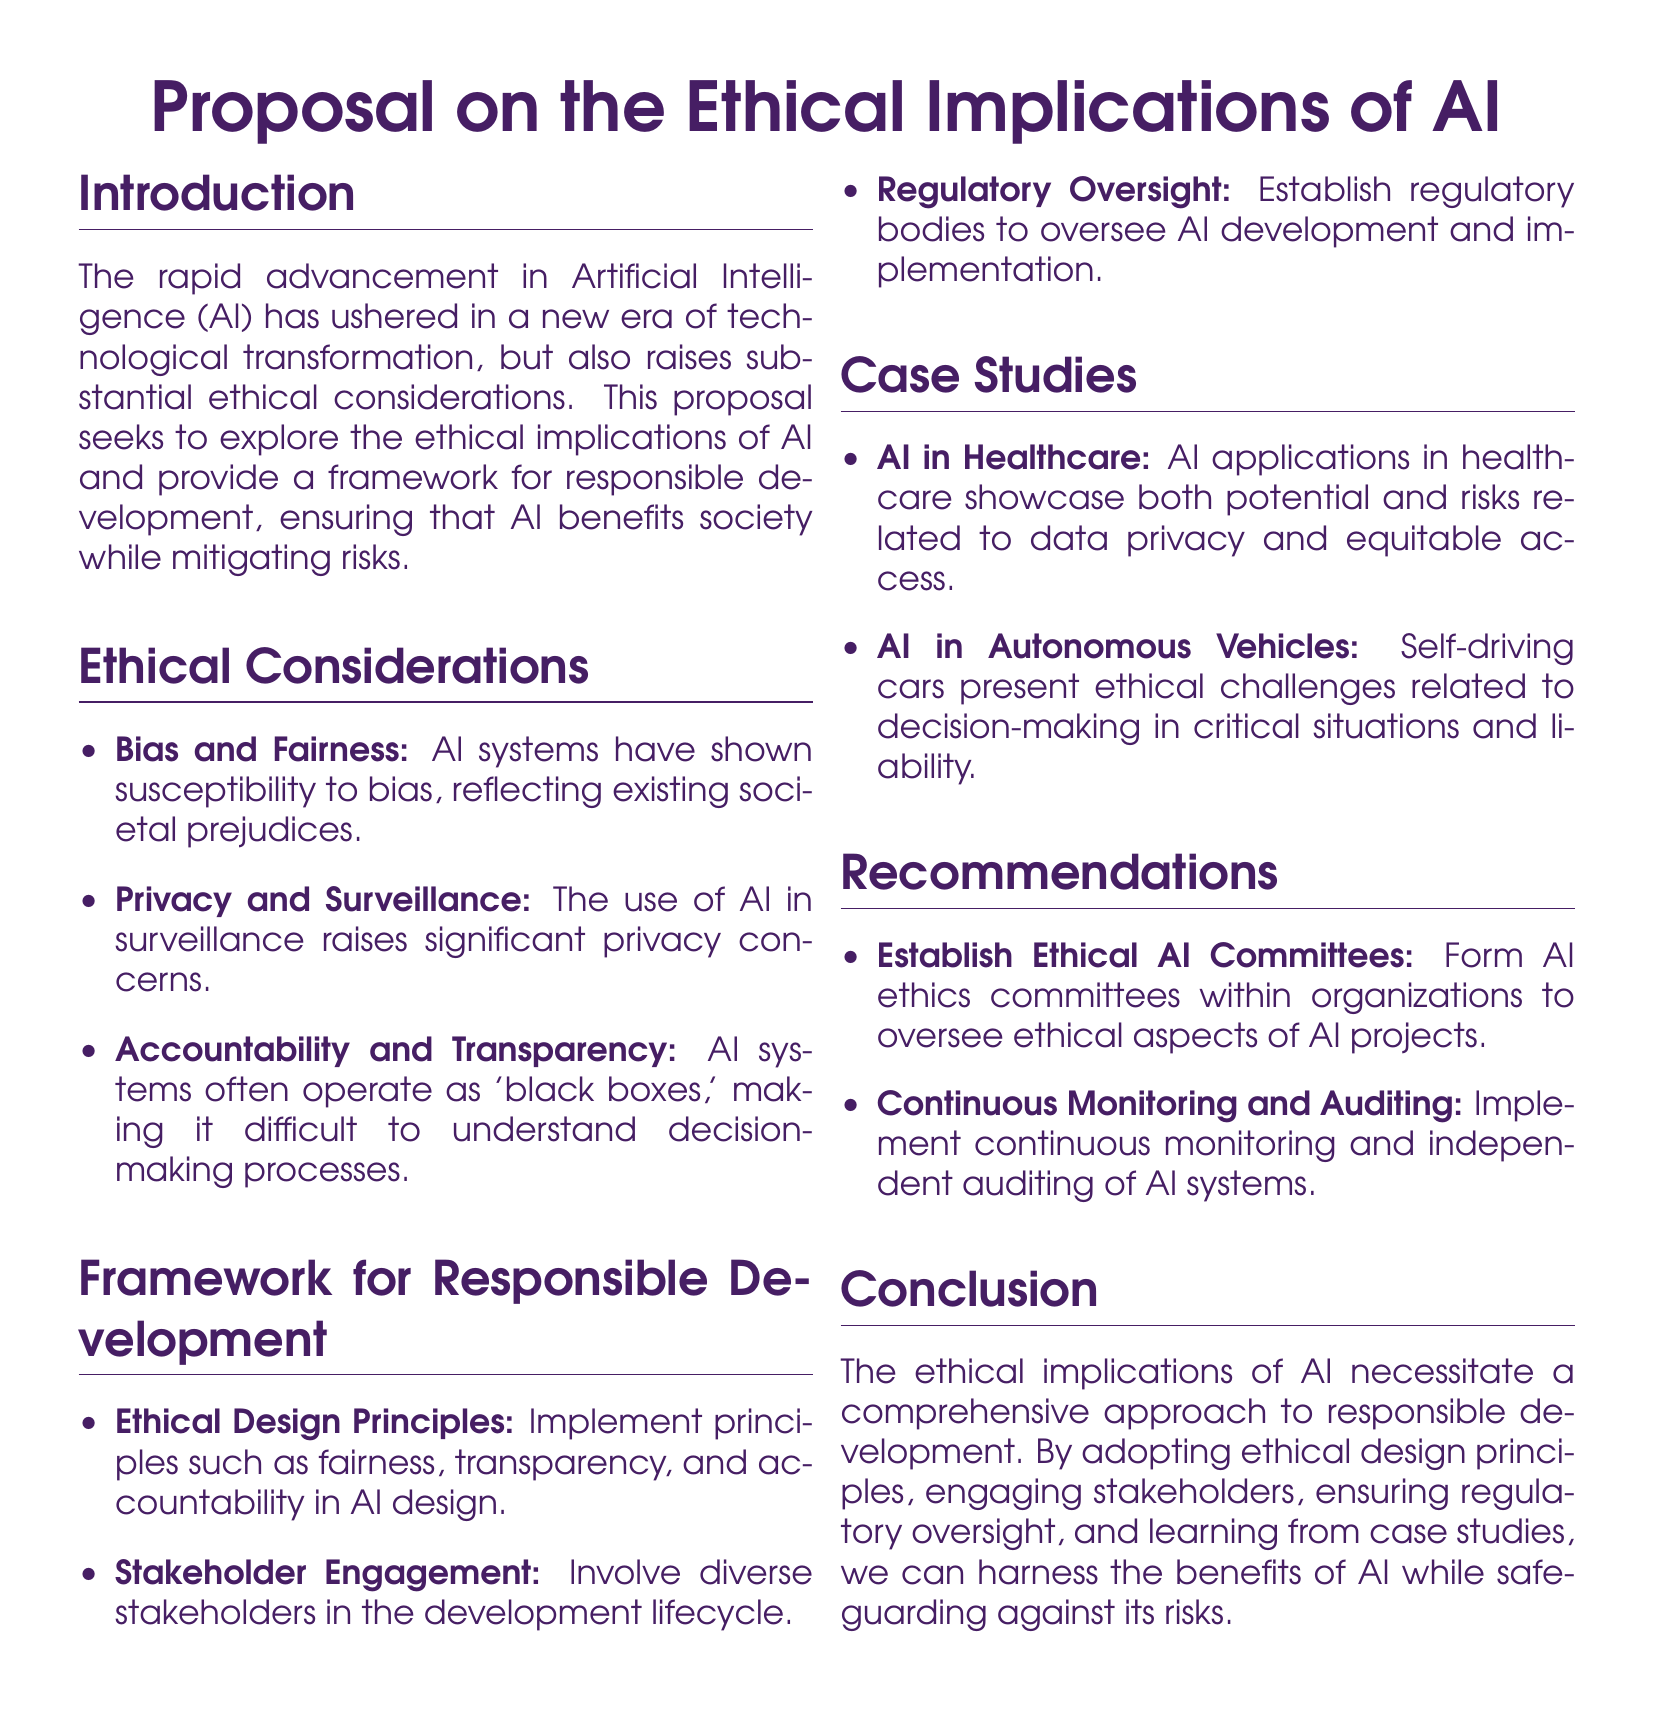What are the main ethical considerations mentioned? The main ethical considerations include bias and fairness, privacy and surveillance, and accountability and transparency.
Answer: bias and fairness, privacy and surveillance, accountability and transparency What is the main purpose of the proposal? The main purpose of the proposal is to explore the ethical implications of AI and provide a framework for responsible development.
Answer: explore the ethical implications of AI and provide a framework for responsible development What is one of the case studies discussed? The proposal outlines specific examples for deeper insight, one of which is AI in healthcare.
Answer: AI in healthcare What is recommended to oversee ethical aspects of AI projects? The proposal suggests forming AI ethics committees within organizations.
Answer: form AI ethics committees What role does stakeholder engagement play? Stakeholder engagement involves diverse stakeholders in the development lifecycle, aiming for inclusivity and varied perspectives.
Answer: involves diverse stakeholders in the development lifecycle What is a proposed method for ensuring transparency in AI? Implementing ethical design principles is proposed as a method for ensuring transparency in AI.
Answer: implementing ethical design principles What should be established for regulatory oversight? Establishing regulatory bodies is recommended for oversight of AI development and implementation.
Answer: establish regulatory bodies What ethical principle is emphasized for AI design? Fairness is emphasized as a key ethical principle for AI design.
Answer: fairness How does the proposal suggest monitoring AI systems? The proposal recommends continuous monitoring and independent auditing for AI systems.
Answer: continuous monitoring and independent auditing 